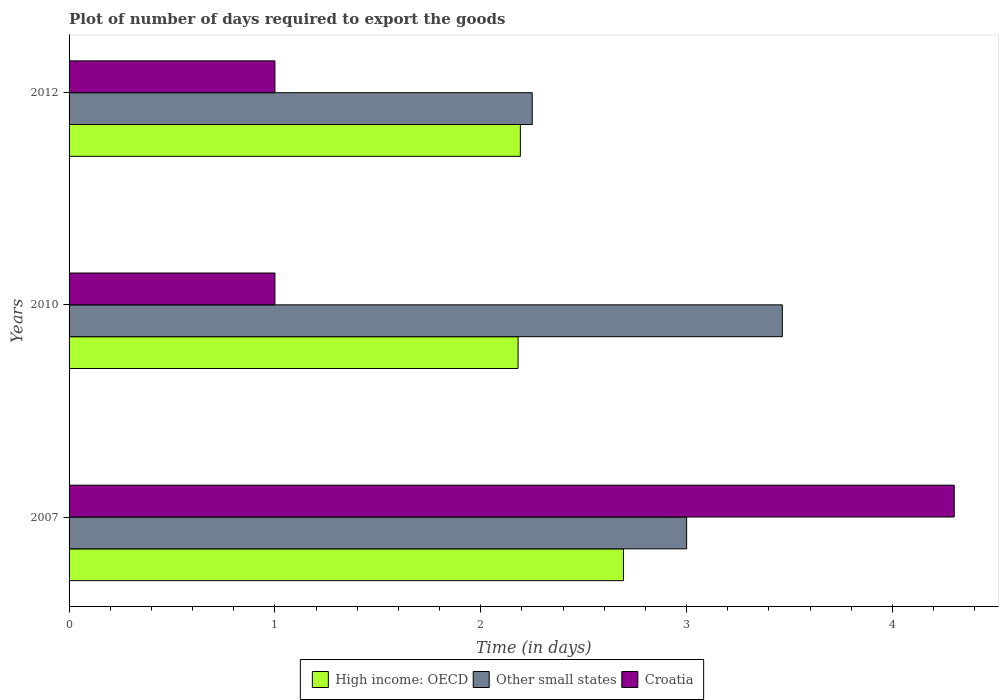How many different coloured bars are there?
Keep it short and to the point. 3. How many bars are there on the 1st tick from the bottom?
Give a very brief answer. 3. In how many cases, is the number of bars for a given year not equal to the number of legend labels?
Offer a terse response. 0. What is the time required to export goods in High income: OECD in 2007?
Provide a short and direct response. 2.69. Across all years, what is the maximum time required to export goods in High income: OECD?
Offer a terse response. 2.69. Across all years, what is the minimum time required to export goods in Other small states?
Your answer should be compact. 2.25. In which year was the time required to export goods in Croatia maximum?
Make the answer very short. 2007. In which year was the time required to export goods in Other small states minimum?
Provide a short and direct response. 2012. What is the total time required to export goods in High income: OECD in the graph?
Give a very brief answer. 7.07. What is the difference between the time required to export goods in Croatia in 2010 and that in 2012?
Ensure brevity in your answer.  0. What is the difference between the time required to export goods in High income: OECD in 2007 and the time required to export goods in Other small states in 2012?
Provide a short and direct response. 0.44. What is the average time required to export goods in High income: OECD per year?
Make the answer very short. 2.36. In the year 2007, what is the difference between the time required to export goods in Other small states and time required to export goods in High income: OECD?
Provide a short and direct response. 0.31. What is the difference between the highest and the second highest time required to export goods in Other small states?
Provide a succinct answer. 0.46. What is the difference between the highest and the lowest time required to export goods in Other small states?
Your answer should be compact. 1.21. Is the sum of the time required to export goods in High income: OECD in 2010 and 2012 greater than the maximum time required to export goods in Croatia across all years?
Give a very brief answer. Yes. What does the 3rd bar from the top in 2012 represents?
Offer a very short reply. High income: OECD. What does the 2nd bar from the bottom in 2012 represents?
Give a very brief answer. Other small states. Is it the case that in every year, the sum of the time required to export goods in High income: OECD and time required to export goods in Croatia is greater than the time required to export goods in Other small states?
Ensure brevity in your answer.  No. Are all the bars in the graph horizontal?
Provide a short and direct response. Yes. How many years are there in the graph?
Provide a succinct answer. 3. Does the graph contain any zero values?
Make the answer very short. No. Where does the legend appear in the graph?
Make the answer very short. Bottom center. How many legend labels are there?
Keep it short and to the point. 3. What is the title of the graph?
Keep it short and to the point. Plot of number of days required to export the goods. Does "World" appear as one of the legend labels in the graph?
Provide a succinct answer. No. What is the label or title of the X-axis?
Keep it short and to the point. Time (in days). What is the label or title of the Y-axis?
Offer a very short reply. Years. What is the Time (in days) of High income: OECD in 2007?
Your response must be concise. 2.69. What is the Time (in days) in High income: OECD in 2010?
Your answer should be very brief. 2.18. What is the Time (in days) of Other small states in 2010?
Provide a short and direct response. 3.46. What is the Time (in days) of Croatia in 2010?
Offer a very short reply. 1. What is the Time (in days) of High income: OECD in 2012?
Provide a short and direct response. 2.19. What is the Time (in days) of Other small states in 2012?
Make the answer very short. 2.25. Across all years, what is the maximum Time (in days) of High income: OECD?
Your response must be concise. 2.69. Across all years, what is the maximum Time (in days) in Other small states?
Your response must be concise. 3.46. Across all years, what is the minimum Time (in days) in High income: OECD?
Your response must be concise. 2.18. Across all years, what is the minimum Time (in days) of Other small states?
Your response must be concise. 2.25. What is the total Time (in days) in High income: OECD in the graph?
Your answer should be compact. 7.07. What is the total Time (in days) in Other small states in the graph?
Make the answer very short. 8.71. What is the difference between the Time (in days) in High income: OECD in 2007 and that in 2010?
Give a very brief answer. 0.51. What is the difference between the Time (in days) in Other small states in 2007 and that in 2010?
Provide a succinct answer. -0.47. What is the difference between the Time (in days) of Croatia in 2007 and that in 2010?
Give a very brief answer. 3.3. What is the difference between the Time (in days) of High income: OECD in 2007 and that in 2012?
Make the answer very short. 0.5. What is the difference between the Time (in days) in Croatia in 2007 and that in 2012?
Give a very brief answer. 3.3. What is the difference between the Time (in days) of High income: OECD in 2010 and that in 2012?
Give a very brief answer. -0.01. What is the difference between the Time (in days) in Other small states in 2010 and that in 2012?
Offer a terse response. 1.22. What is the difference between the Time (in days) in Croatia in 2010 and that in 2012?
Your response must be concise. 0. What is the difference between the Time (in days) of High income: OECD in 2007 and the Time (in days) of Other small states in 2010?
Ensure brevity in your answer.  -0.77. What is the difference between the Time (in days) of High income: OECD in 2007 and the Time (in days) of Croatia in 2010?
Keep it short and to the point. 1.69. What is the difference between the Time (in days) in Other small states in 2007 and the Time (in days) in Croatia in 2010?
Your answer should be compact. 2. What is the difference between the Time (in days) in High income: OECD in 2007 and the Time (in days) in Other small states in 2012?
Your response must be concise. 0.44. What is the difference between the Time (in days) of High income: OECD in 2007 and the Time (in days) of Croatia in 2012?
Offer a very short reply. 1.69. What is the difference between the Time (in days) of High income: OECD in 2010 and the Time (in days) of Other small states in 2012?
Ensure brevity in your answer.  -0.07. What is the difference between the Time (in days) of High income: OECD in 2010 and the Time (in days) of Croatia in 2012?
Your answer should be compact. 1.18. What is the difference between the Time (in days) in Other small states in 2010 and the Time (in days) in Croatia in 2012?
Offer a very short reply. 2.46. What is the average Time (in days) in High income: OECD per year?
Offer a very short reply. 2.36. What is the average Time (in days) in Other small states per year?
Keep it short and to the point. 2.9. What is the average Time (in days) of Croatia per year?
Offer a very short reply. 2.1. In the year 2007, what is the difference between the Time (in days) of High income: OECD and Time (in days) of Other small states?
Offer a very short reply. -0.31. In the year 2007, what is the difference between the Time (in days) in High income: OECD and Time (in days) in Croatia?
Your response must be concise. -1.61. In the year 2010, what is the difference between the Time (in days) in High income: OECD and Time (in days) in Other small states?
Provide a succinct answer. -1.28. In the year 2010, what is the difference between the Time (in days) of High income: OECD and Time (in days) of Croatia?
Offer a terse response. 1.18. In the year 2010, what is the difference between the Time (in days) of Other small states and Time (in days) of Croatia?
Your response must be concise. 2.46. In the year 2012, what is the difference between the Time (in days) of High income: OECD and Time (in days) of Other small states?
Offer a very short reply. -0.06. In the year 2012, what is the difference between the Time (in days) of High income: OECD and Time (in days) of Croatia?
Give a very brief answer. 1.19. In the year 2012, what is the difference between the Time (in days) in Other small states and Time (in days) in Croatia?
Provide a short and direct response. 1.25. What is the ratio of the Time (in days) of High income: OECD in 2007 to that in 2010?
Offer a terse response. 1.23. What is the ratio of the Time (in days) in Other small states in 2007 to that in 2010?
Provide a short and direct response. 0.87. What is the ratio of the Time (in days) in High income: OECD in 2007 to that in 2012?
Offer a terse response. 1.23. What is the ratio of the Time (in days) in Croatia in 2007 to that in 2012?
Provide a succinct answer. 4.3. What is the ratio of the Time (in days) of Other small states in 2010 to that in 2012?
Your response must be concise. 1.54. What is the difference between the highest and the second highest Time (in days) of High income: OECD?
Your answer should be very brief. 0.5. What is the difference between the highest and the second highest Time (in days) of Other small states?
Give a very brief answer. 0.47. What is the difference between the highest and the lowest Time (in days) of High income: OECD?
Provide a succinct answer. 0.51. What is the difference between the highest and the lowest Time (in days) of Other small states?
Provide a short and direct response. 1.22. 